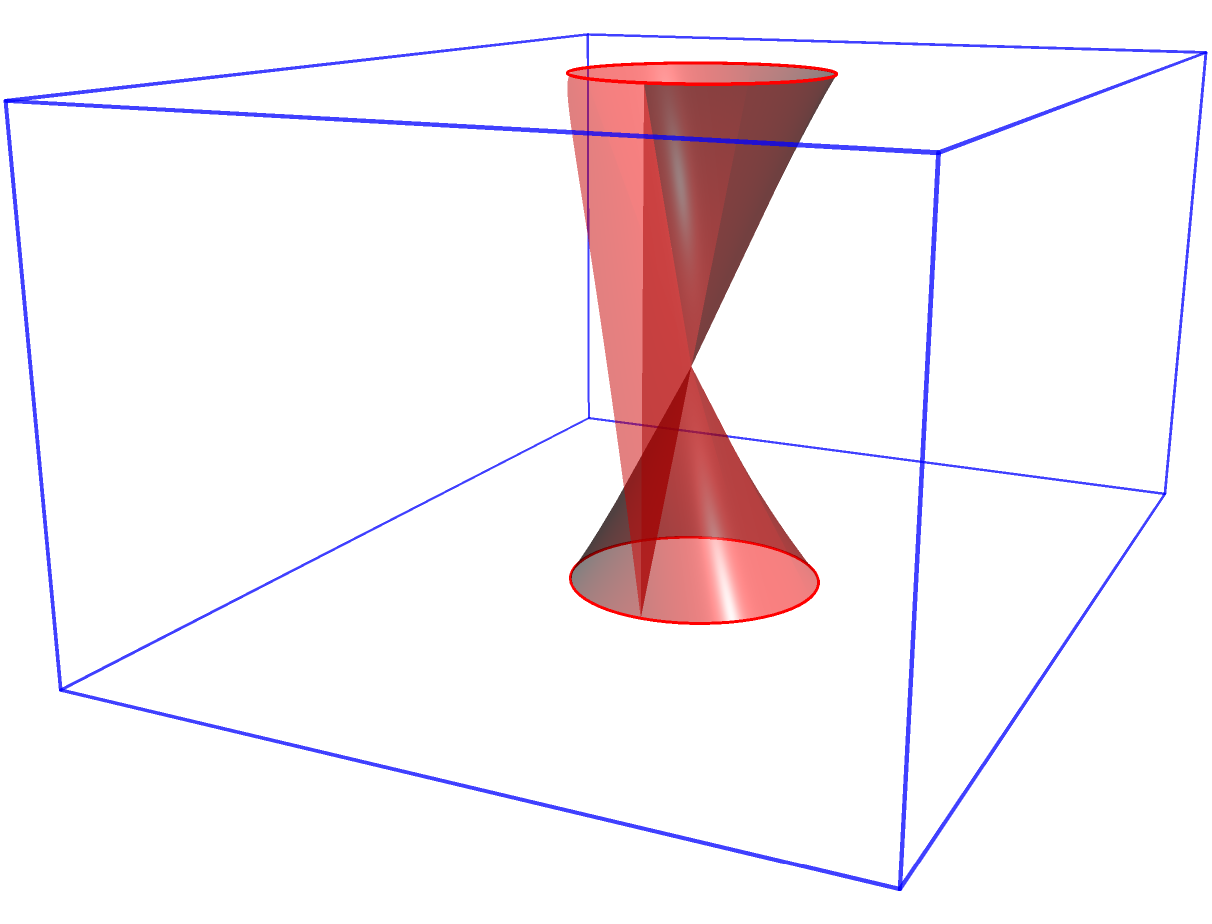A rectangular prism has dimensions 4 units in length, 3 units in width, and 2 units in height. A cylindrical hole with a radius of 0.5 units is drilled through the center of the prism, parallel to its height. Calculate the total surface area of the resulting object, including the inner surface of the cylindrical hole. Round your answer to two decimal places. To solve this problem, we need to follow these steps:

1) Calculate the surface area of the rectangular prism without the hole:
   $$SA_{prism} = 2(lw + lh + wh)$$
   $$SA_{prism} = 2(4 \cdot 3 + 4 \cdot 2 + 3 \cdot 2) = 2(12 + 8 + 6) = 2(26) = 52$$

2) Calculate the area of the circular holes on the top and bottom faces:
   $$A_{circle} = \pi r^2 = \pi (0.5)^2 = 0.25\pi$$

3) Subtract the area of these two circular holes:
   $$SA_{without holes} = 52 - 2(0.25\pi) = 52 - 0.5\pi$$

4) Calculate the surface area of the cylindrical hole:
   $$SA_{cylinder} = 2\pi rh = 2\pi (0.5)(2) = 2\pi$$

5) Add the surface area of the cylindrical hole to get the total surface area:
   $$SA_{total} = (52 - 0.5\pi) + 2\pi = 52 + 1.5\pi$$

6) Calculate the final result:
   $$SA_{total} = 52 + 1.5\pi \approx 56.71$$

Rounding to two decimal places, we get 56.71 square units.
Answer: 56.71 square units 